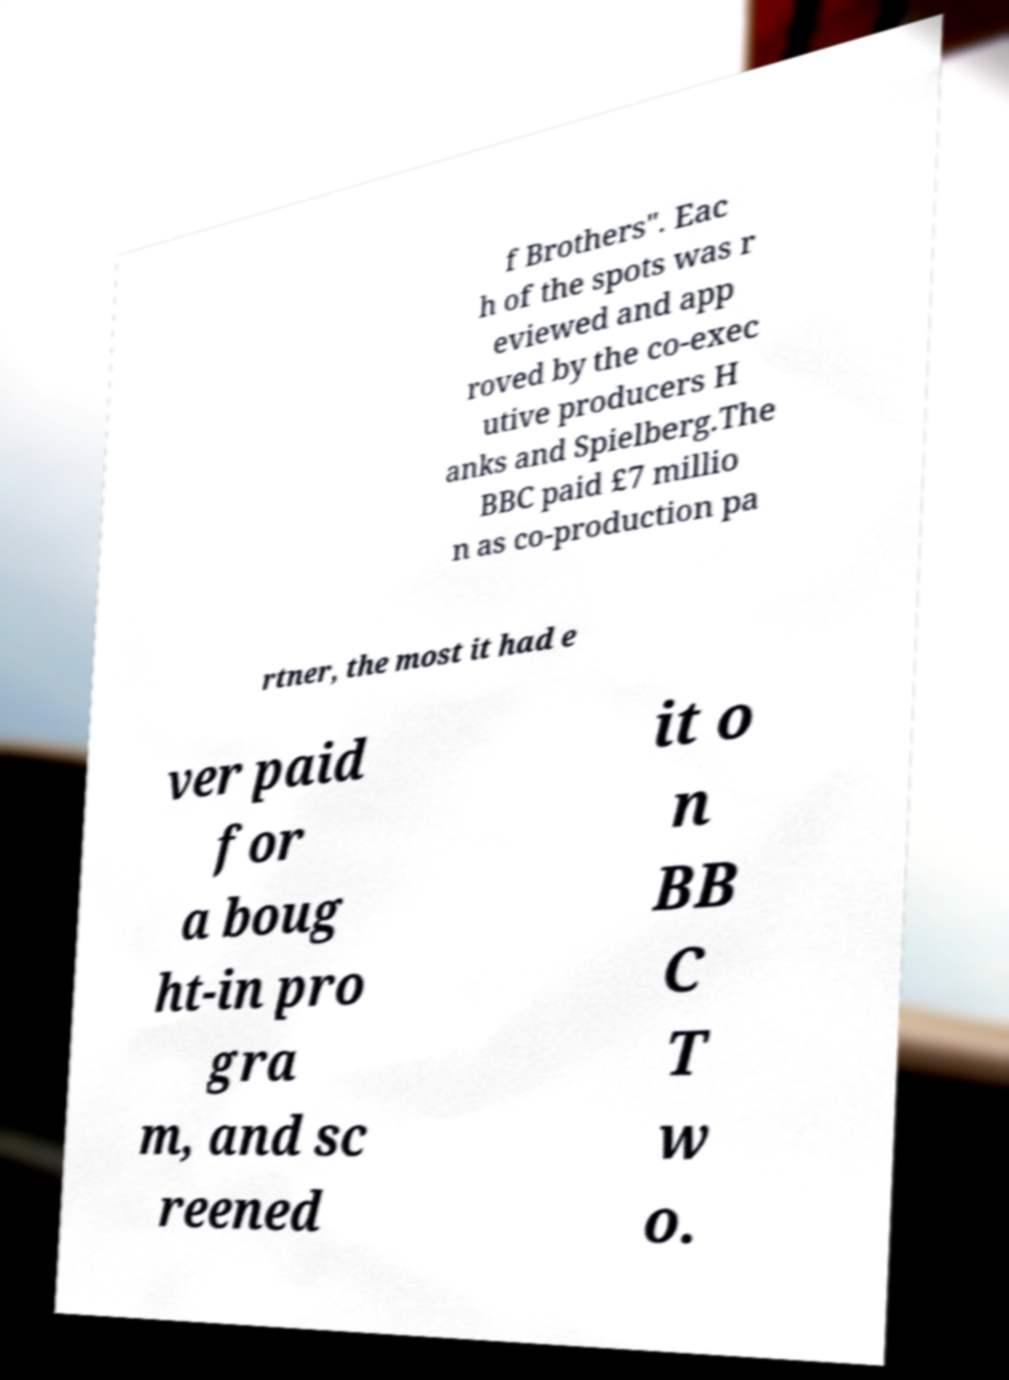Could you assist in decoding the text presented in this image and type it out clearly? f Brothers". Eac h of the spots was r eviewed and app roved by the co-exec utive producers H anks and Spielberg.The BBC paid £7 millio n as co-production pa rtner, the most it had e ver paid for a boug ht-in pro gra m, and sc reened it o n BB C T w o. 